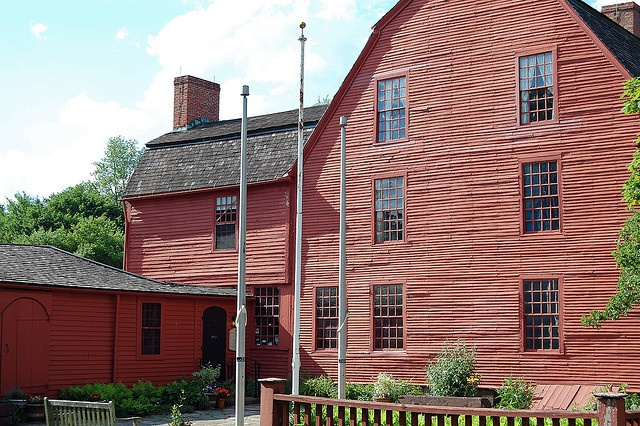Describe the objects in this image and their specific colors. I can see potted plant in lightblue, black, gray, olive, and darkgray tones, bench in lightblue, black, gray, and darkgreen tones, potted plant in lightblue, darkgreen, black, and olive tones, potted plant in lightblue, olive, darkgreen, black, and gray tones, and potted plant in lightblue, black, darkgreen, and maroon tones in this image. 